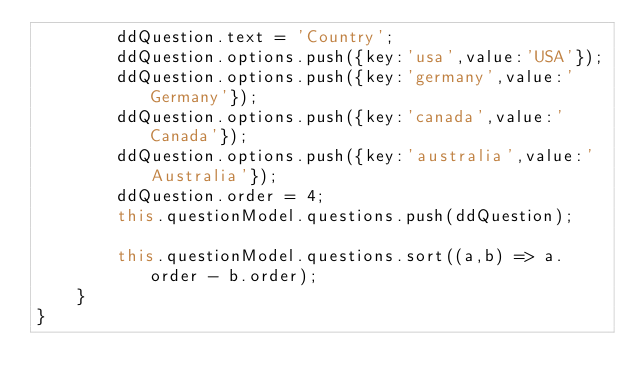Convert code to text. <code><loc_0><loc_0><loc_500><loc_500><_TypeScript_>        ddQuestion.text = 'Country';
        ddQuestion.options.push({key:'usa',value:'USA'});
        ddQuestion.options.push({key:'germany',value:'Germany'});
        ddQuestion.options.push({key:'canada',value:'Canada'});
        ddQuestion.options.push({key:'australia',value:'Australia'});
        ddQuestion.order = 4;
        this.questionModel.questions.push(ddQuestion);

        this.questionModel.questions.sort((a,b) => a.order - b.order);
    }
}</code> 